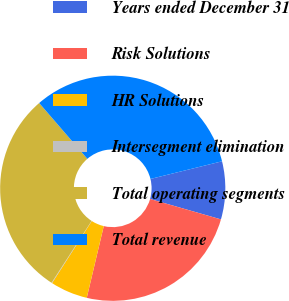<chart> <loc_0><loc_0><loc_500><loc_500><pie_chart><fcel>Years ended December 31<fcel>Risk Solutions<fcel>HR Solutions<fcel>Intersegment elimination<fcel>Total operating segments<fcel>Total revenue<nl><fcel>8.31%<fcel>24.25%<fcel>5.36%<fcel>0.08%<fcel>29.53%<fcel>32.48%<nl></chart> 